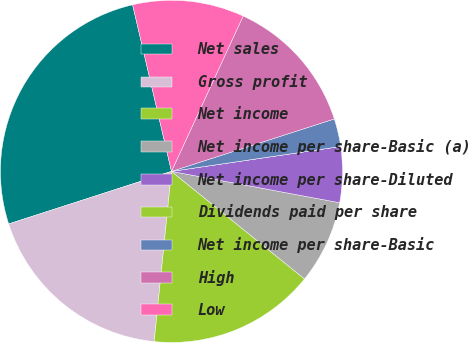<chart> <loc_0><loc_0><loc_500><loc_500><pie_chart><fcel>Net sales<fcel>Gross profit<fcel>Net income<fcel>Net income per share-Basic (a)<fcel>Net income per share-Diluted<fcel>Dividends paid per share<fcel>Net income per share-Basic<fcel>High<fcel>Low<nl><fcel>26.32%<fcel>18.42%<fcel>15.79%<fcel>7.89%<fcel>5.26%<fcel>0.0%<fcel>2.63%<fcel>13.16%<fcel>10.53%<nl></chart> 